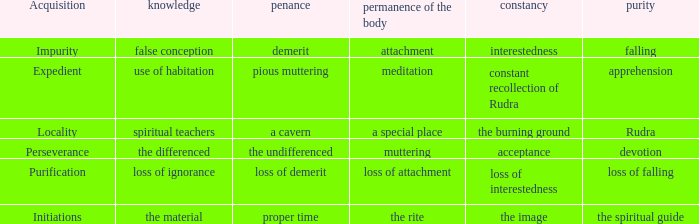 what's the constancy where permanence of the body is meditation Constant recollection of rudra. 